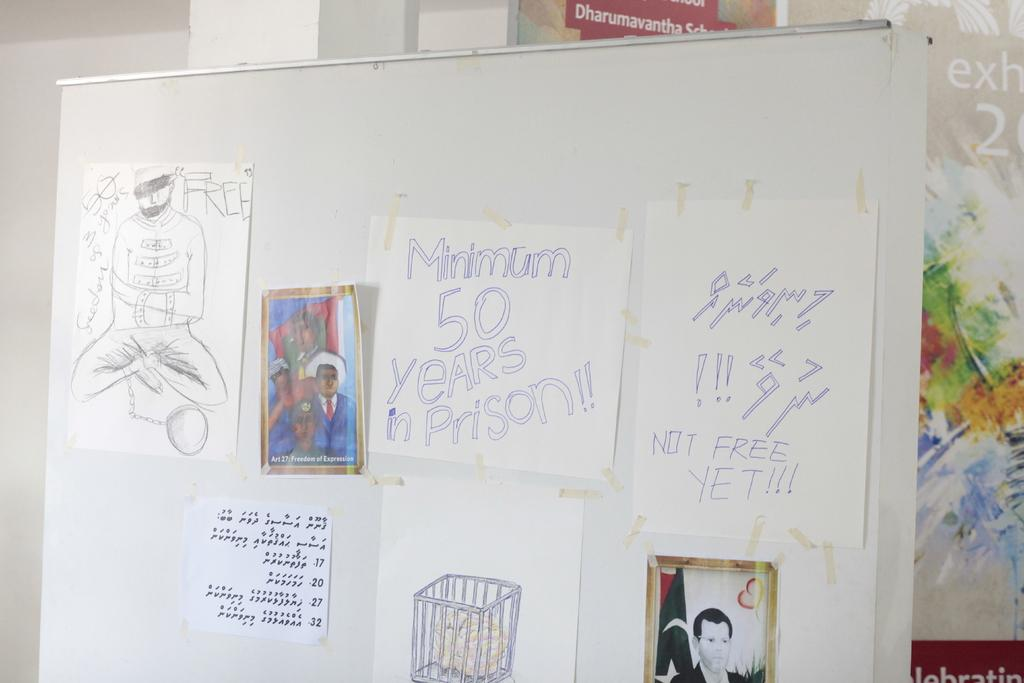Provide a one-sentence caption for the provided image. A white board with multiple pictures/drawings hung, one of them says Minimum 50 years in prison. 